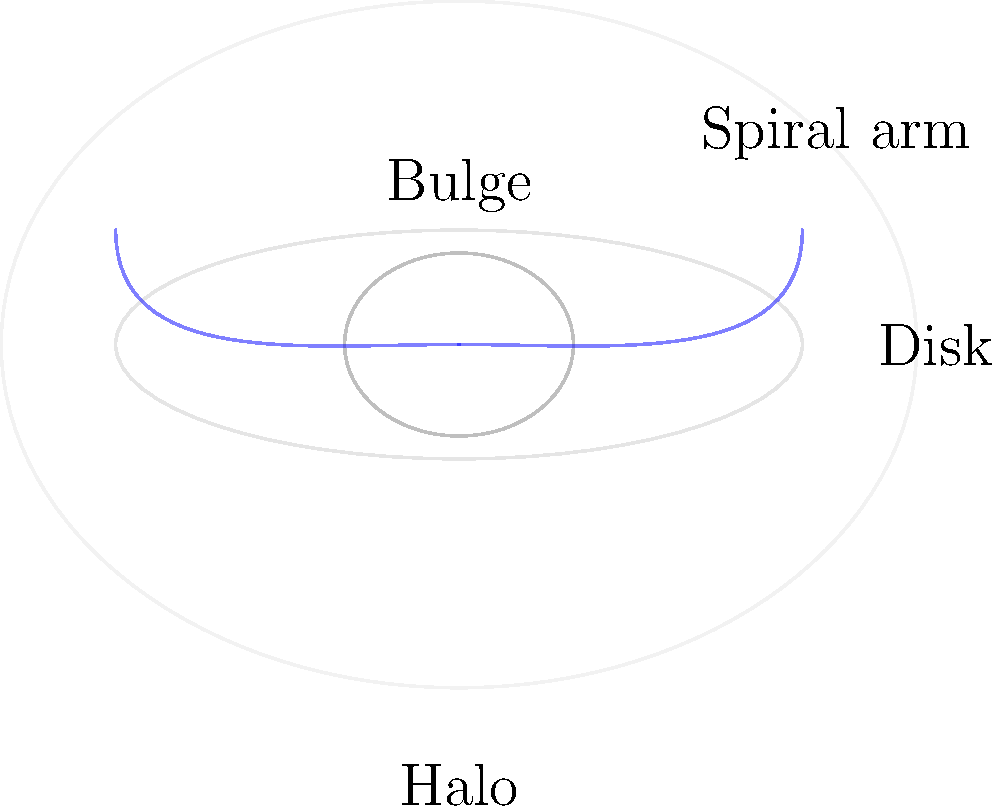While driving home from your astronomy club meeting, you recall discussing the structure of spiral galaxies. Which component of a spiral galaxy contains the oldest stars and extends far beyond the visible disk? Let's break down the main components of a typical spiral galaxy:

1. Disk: This is the flat, circular region where most of the galaxy's stars, gas, and dust are located. It contains both young and old stars.

2. Bulge: This is the central, spheroidal region of the galaxy. It primarily contains older stars.

3. Spiral arms: These are the bright, curved structures that give spiral galaxies their distinctive appearance. They contain many young stars, as well as gas and dust for new star formation.

4. Halo: This is a sparse, spherical region that extends far beyond the visible disk of the galaxy. It contains the oldest stars in the galaxy, as well as globular clusters.

The key to answering this question is understanding that the halo:
a) Contains the oldest stars in the galaxy
b) Extends much farther out than the visible disk

While the bulge also contains old stars, it doesn't extend beyond the visible disk. Therefore, the component that best fits the description in the question is the halo.
Answer: Halo 